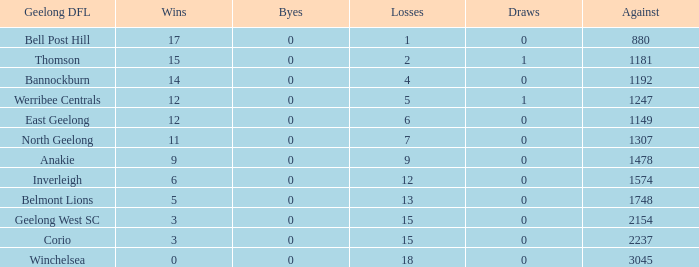What is the highest number of byes where the losses were 9 and the draws were less than 0? None. 